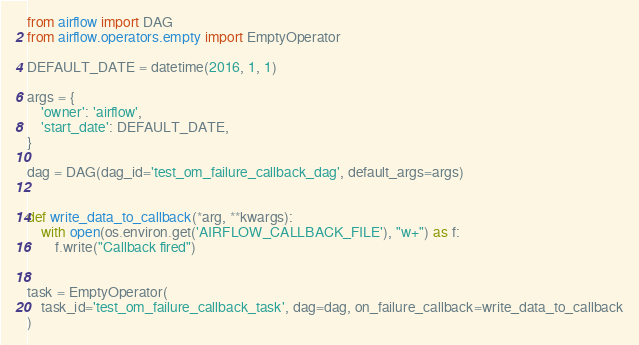Convert code to text. <code><loc_0><loc_0><loc_500><loc_500><_Python_>from airflow import DAG
from airflow.operators.empty import EmptyOperator

DEFAULT_DATE = datetime(2016, 1, 1)

args = {
    'owner': 'airflow',
    'start_date': DEFAULT_DATE,
}

dag = DAG(dag_id='test_om_failure_callback_dag', default_args=args)


def write_data_to_callback(*arg, **kwargs):
    with open(os.environ.get('AIRFLOW_CALLBACK_FILE'), "w+") as f:
        f.write("Callback fired")


task = EmptyOperator(
    task_id='test_om_failure_callback_task', dag=dag, on_failure_callback=write_data_to_callback
)
</code> 